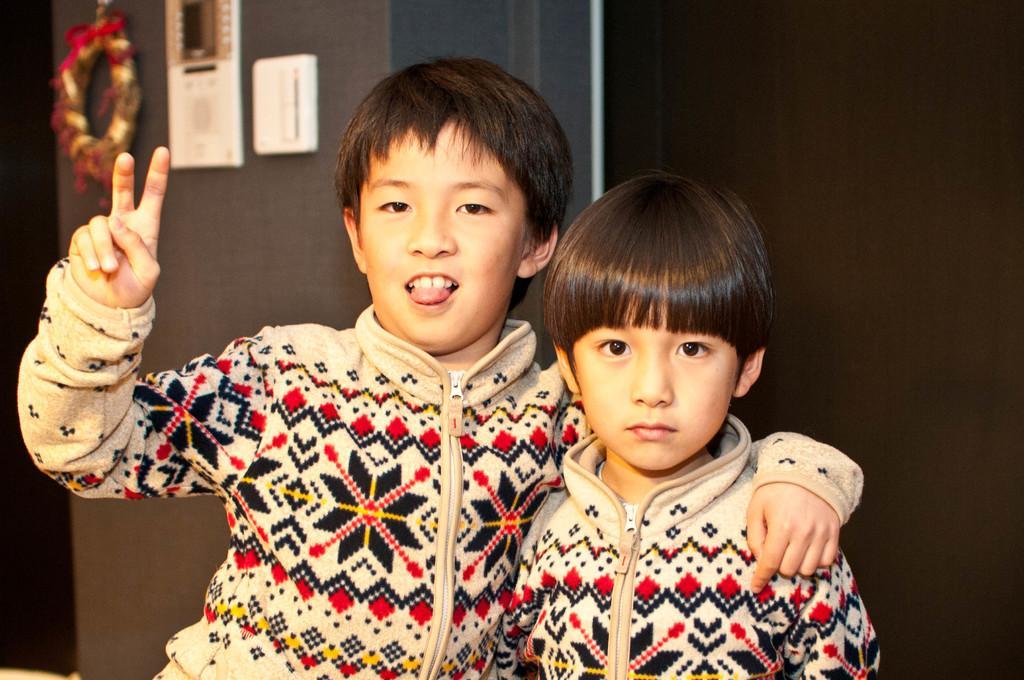Please provide a concise description of this image. In this image I can see two boys are wearing same jackets and giving pose for the picture. In the background, I can see a wall to which few objects are attached. 